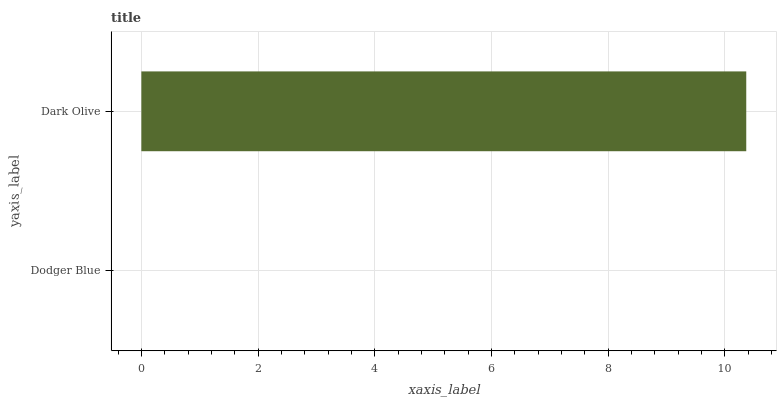Is Dodger Blue the minimum?
Answer yes or no. Yes. Is Dark Olive the maximum?
Answer yes or no. Yes. Is Dark Olive the minimum?
Answer yes or no. No. Is Dark Olive greater than Dodger Blue?
Answer yes or no. Yes. Is Dodger Blue less than Dark Olive?
Answer yes or no. Yes. Is Dodger Blue greater than Dark Olive?
Answer yes or no. No. Is Dark Olive less than Dodger Blue?
Answer yes or no. No. Is Dark Olive the high median?
Answer yes or no. Yes. Is Dodger Blue the low median?
Answer yes or no. Yes. Is Dodger Blue the high median?
Answer yes or no. No. Is Dark Olive the low median?
Answer yes or no. No. 